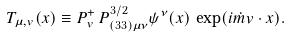Convert formula to latex. <formula><loc_0><loc_0><loc_500><loc_500>T _ { \mu , v } ( x ) \equiv P _ { v } ^ { + } \, P ^ { 3 / 2 } _ { ( 3 3 ) \mu \nu } \psi ^ { \nu } ( x ) \, \exp ( i \dot { m } v \cdot x ) .</formula> 